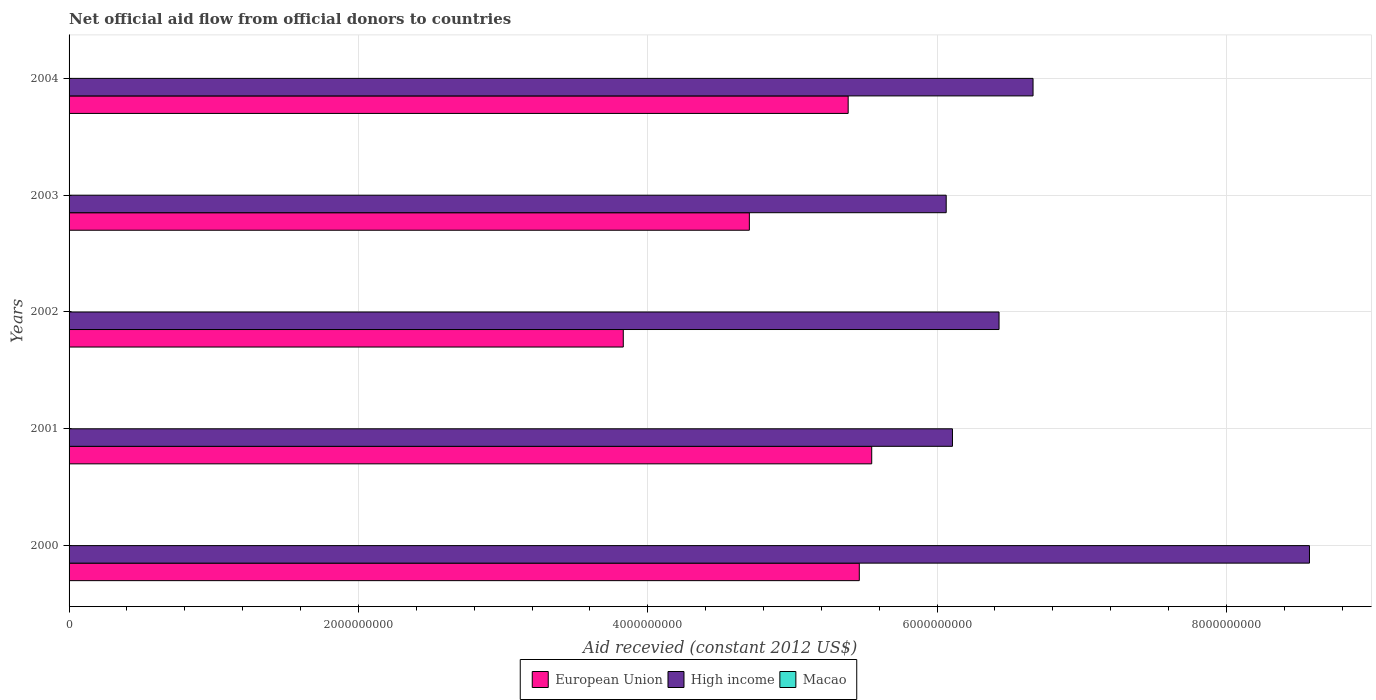How many different coloured bars are there?
Keep it short and to the point. 3. How many groups of bars are there?
Your answer should be very brief. 5. Are the number of bars per tick equal to the number of legend labels?
Offer a very short reply. Yes. How many bars are there on the 3rd tick from the bottom?
Offer a very short reply. 3. What is the label of the 3rd group of bars from the top?
Your answer should be very brief. 2002. What is the total aid received in European Union in 2003?
Offer a terse response. 4.70e+09. Across all years, what is the maximum total aid received in Macao?
Your answer should be compact. 1.58e+06. Across all years, what is the minimum total aid received in High income?
Your answer should be very brief. 6.06e+09. In which year was the total aid received in Macao maximum?
Make the answer very short. 2002. What is the total total aid received in High income in the graph?
Give a very brief answer. 3.38e+1. What is the difference between the total aid received in High income in 2000 and that in 2003?
Your answer should be compact. 2.51e+09. What is the difference between the total aid received in High income in 2000 and the total aid received in Macao in 2003?
Your response must be concise. 8.57e+09. What is the average total aid received in Macao per year?
Your response must be concise. 7.70e+05. In the year 2004, what is the difference between the total aid received in Macao and total aid received in High income?
Keep it short and to the point. -6.66e+09. What is the ratio of the total aid received in High income in 2001 to that in 2003?
Your answer should be very brief. 1.01. Is the difference between the total aid received in Macao in 2003 and 2004 greater than the difference between the total aid received in High income in 2003 and 2004?
Offer a terse response. Yes. What is the difference between the highest and the second highest total aid received in High income?
Keep it short and to the point. 1.91e+09. What is the difference between the highest and the lowest total aid received in High income?
Make the answer very short. 2.51e+09. In how many years, is the total aid received in European Union greater than the average total aid received in European Union taken over all years?
Keep it short and to the point. 3. What does the 2nd bar from the bottom in 2004 represents?
Make the answer very short. High income. How many bars are there?
Your answer should be compact. 15. Are all the bars in the graph horizontal?
Your response must be concise. Yes. How many years are there in the graph?
Give a very brief answer. 5. What is the difference between two consecutive major ticks on the X-axis?
Ensure brevity in your answer.  2.00e+09. Does the graph contain grids?
Offer a terse response. Yes. Where does the legend appear in the graph?
Offer a very short reply. Bottom center. How are the legend labels stacked?
Offer a very short reply. Horizontal. What is the title of the graph?
Keep it short and to the point. Net official aid flow from official donors to countries. What is the label or title of the X-axis?
Give a very brief answer. Aid recevied (constant 2012 US$). What is the Aid recevied (constant 2012 US$) of European Union in 2000?
Your response must be concise. 5.46e+09. What is the Aid recevied (constant 2012 US$) in High income in 2000?
Keep it short and to the point. 8.57e+09. What is the Aid recevied (constant 2012 US$) in Macao in 2000?
Your response must be concise. 1.08e+06. What is the Aid recevied (constant 2012 US$) of European Union in 2001?
Provide a succinct answer. 5.55e+09. What is the Aid recevied (constant 2012 US$) of High income in 2001?
Your answer should be very brief. 6.11e+09. What is the Aid recevied (constant 2012 US$) in Macao in 2001?
Your answer should be compact. 8.60e+05. What is the Aid recevied (constant 2012 US$) of European Union in 2002?
Provide a short and direct response. 3.83e+09. What is the Aid recevied (constant 2012 US$) in High income in 2002?
Your response must be concise. 6.43e+09. What is the Aid recevied (constant 2012 US$) of Macao in 2002?
Your response must be concise. 1.58e+06. What is the Aid recevied (constant 2012 US$) of European Union in 2003?
Your answer should be very brief. 4.70e+09. What is the Aid recevied (constant 2012 US$) of High income in 2003?
Ensure brevity in your answer.  6.06e+09. What is the Aid recevied (constant 2012 US$) of Macao in 2003?
Keep it short and to the point. 1.80e+05. What is the Aid recevied (constant 2012 US$) in European Union in 2004?
Provide a short and direct response. 5.39e+09. What is the Aid recevied (constant 2012 US$) of High income in 2004?
Make the answer very short. 6.66e+09. What is the Aid recevied (constant 2012 US$) in Macao in 2004?
Your answer should be compact. 1.50e+05. Across all years, what is the maximum Aid recevied (constant 2012 US$) of European Union?
Offer a terse response. 5.55e+09. Across all years, what is the maximum Aid recevied (constant 2012 US$) of High income?
Provide a succinct answer. 8.57e+09. Across all years, what is the maximum Aid recevied (constant 2012 US$) of Macao?
Your answer should be compact. 1.58e+06. Across all years, what is the minimum Aid recevied (constant 2012 US$) in European Union?
Provide a succinct answer. 3.83e+09. Across all years, what is the minimum Aid recevied (constant 2012 US$) in High income?
Make the answer very short. 6.06e+09. What is the total Aid recevied (constant 2012 US$) in European Union in the graph?
Provide a succinct answer. 2.49e+1. What is the total Aid recevied (constant 2012 US$) in High income in the graph?
Provide a succinct answer. 3.38e+1. What is the total Aid recevied (constant 2012 US$) in Macao in the graph?
Your answer should be very brief. 3.85e+06. What is the difference between the Aid recevied (constant 2012 US$) of European Union in 2000 and that in 2001?
Make the answer very short. -8.58e+07. What is the difference between the Aid recevied (constant 2012 US$) of High income in 2000 and that in 2001?
Your answer should be compact. 2.47e+09. What is the difference between the Aid recevied (constant 2012 US$) of Macao in 2000 and that in 2001?
Offer a terse response. 2.20e+05. What is the difference between the Aid recevied (constant 2012 US$) of European Union in 2000 and that in 2002?
Ensure brevity in your answer.  1.63e+09. What is the difference between the Aid recevied (constant 2012 US$) of High income in 2000 and that in 2002?
Provide a succinct answer. 2.15e+09. What is the difference between the Aid recevied (constant 2012 US$) in Macao in 2000 and that in 2002?
Keep it short and to the point. -5.00e+05. What is the difference between the Aid recevied (constant 2012 US$) of European Union in 2000 and that in 2003?
Ensure brevity in your answer.  7.60e+08. What is the difference between the Aid recevied (constant 2012 US$) in High income in 2000 and that in 2003?
Your answer should be compact. 2.51e+09. What is the difference between the Aid recevied (constant 2012 US$) of Macao in 2000 and that in 2003?
Ensure brevity in your answer.  9.00e+05. What is the difference between the Aid recevied (constant 2012 US$) in European Union in 2000 and that in 2004?
Give a very brief answer. 7.69e+07. What is the difference between the Aid recevied (constant 2012 US$) of High income in 2000 and that in 2004?
Your answer should be compact. 1.91e+09. What is the difference between the Aid recevied (constant 2012 US$) in Macao in 2000 and that in 2004?
Keep it short and to the point. 9.30e+05. What is the difference between the Aid recevied (constant 2012 US$) of European Union in 2001 and that in 2002?
Ensure brevity in your answer.  1.72e+09. What is the difference between the Aid recevied (constant 2012 US$) of High income in 2001 and that in 2002?
Give a very brief answer. -3.22e+08. What is the difference between the Aid recevied (constant 2012 US$) of Macao in 2001 and that in 2002?
Keep it short and to the point. -7.20e+05. What is the difference between the Aid recevied (constant 2012 US$) of European Union in 2001 and that in 2003?
Provide a short and direct response. 8.46e+08. What is the difference between the Aid recevied (constant 2012 US$) in High income in 2001 and that in 2003?
Keep it short and to the point. 4.32e+07. What is the difference between the Aid recevied (constant 2012 US$) in Macao in 2001 and that in 2003?
Offer a very short reply. 6.80e+05. What is the difference between the Aid recevied (constant 2012 US$) of European Union in 2001 and that in 2004?
Ensure brevity in your answer.  1.63e+08. What is the difference between the Aid recevied (constant 2012 US$) in High income in 2001 and that in 2004?
Make the answer very short. -5.57e+08. What is the difference between the Aid recevied (constant 2012 US$) of Macao in 2001 and that in 2004?
Your response must be concise. 7.10e+05. What is the difference between the Aid recevied (constant 2012 US$) of European Union in 2002 and that in 2003?
Provide a short and direct response. -8.71e+08. What is the difference between the Aid recevied (constant 2012 US$) in High income in 2002 and that in 2003?
Your response must be concise. 3.65e+08. What is the difference between the Aid recevied (constant 2012 US$) in Macao in 2002 and that in 2003?
Provide a succinct answer. 1.40e+06. What is the difference between the Aid recevied (constant 2012 US$) in European Union in 2002 and that in 2004?
Offer a terse response. -1.55e+09. What is the difference between the Aid recevied (constant 2012 US$) of High income in 2002 and that in 2004?
Provide a succinct answer. -2.35e+08. What is the difference between the Aid recevied (constant 2012 US$) of Macao in 2002 and that in 2004?
Your answer should be compact. 1.43e+06. What is the difference between the Aid recevied (constant 2012 US$) of European Union in 2003 and that in 2004?
Keep it short and to the point. -6.83e+08. What is the difference between the Aid recevied (constant 2012 US$) of High income in 2003 and that in 2004?
Make the answer very short. -6.00e+08. What is the difference between the Aid recevied (constant 2012 US$) of Macao in 2003 and that in 2004?
Your answer should be very brief. 3.00e+04. What is the difference between the Aid recevied (constant 2012 US$) in European Union in 2000 and the Aid recevied (constant 2012 US$) in High income in 2001?
Make the answer very short. -6.44e+08. What is the difference between the Aid recevied (constant 2012 US$) in European Union in 2000 and the Aid recevied (constant 2012 US$) in Macao in 2001?
Your answer should be compact. 5.46e+09. What is the difference between the Aid recevied (constant 2012 US$) of High income in 2000 and the Aid recevied (constant 2012 US$) of Macao in 2001?
Your answer should be very brief. 8.57e+09. What is the difference between the Aid recevied (constant 2012 US$) of European Union in 2000 and the Aid recevied (constant 2012 US$) of High income in 2002?
Your answer should be compact. -9.66e+08. What is the difference between the Aid recevied (constant 2012 US$) of European Union in 2000 and the Aid recevied (constant 2012 US$) of Macao in 2002?
Ensure brevity in your answer.  5.46e+09. What is the difference between the Aid recevied (constant 2012 US$) of High income in 2000 and the Aid recevied (constant 2012 US$) of Macao in 2002?
Your answer should be very brief. 8.57e+09. What is the difference between the Aid recevied (constant 2012 US$) of European Union in 2000 and the Aid recevied (constant 2012 US$) of High income in 2003?
Give a very brief answer. -6.01e+08. What is the difference between the Aid recevied (constant 2012 US$) in European Union in 2000 and the Aid recevied (constant 2012 US$) in Macao in 2003?
Keep it short and to the point. 5.46e+09. What is the difference between the Aid recevied (constant 2012 US$) of High income in 2000 and the Aid recevied (constant 2012 US$) of Macao in 2003?
Offer a terse response. 8.57e+09. What is the difference between the Aid recevied (constant 2012 US$) of European Union in 2000 and the Aid recevied (constant 2012 US$) of High income in 2004?
Make the answer very short. -1.20e+09. What is the difference between the Aid recevied (constant 2012 US$) in European Union in 2000 and the Aid recevied (constant 2012 US$) in Macao in 2004?
Make the answer very short. 5.46e+09. What is the difference between the Aid recevied (constant 2012 US$) in High income in 2000 and the Aid recevied (constant 2012 US$) in Macao in 2004?
Make the answer very short. 8.57e+09. What is the difference between the Aid recevied (constant 2012 US$) in European Union in 2001 and the Aid recevied (constant 2012 US$) in High income in 2002?
Give a very brief answer. -8.80e+08. What is the difference between the Aid recevied (constant 2012 US$) in European Union in 2001 and the Aid recevied (constant 2012 US$) in Macao in 2002?
Your response must be concise. 5.55e+09. What is the difference between the Aid recevied (constant 2012 US$) of High income in 2001 and the Aid recevied (constant 2012 US$) of Macao in 2002?
Make the answer very short. 6.10e+09. What is the difference between the Aid recevied (constant 2012 US$) of European Union in 2001 and the Aid recevied (constant 2012 US$) of High income in 2003?
Offer a terse response. -5.15e+08. What is the difference between the Aid recevied (constant 2012 US$) of European Union in 2001 and the Aid recevied (constant 2012 US$) of Macao in 2003?
Make the answer very short. 5.55e+09. What is the difference between the Aid recevied (constant 2012 US$) in High income in 2001 and the Aid recevied (constant 2012 US$) in Macao in 2003?
Make the answer very short. 6.11e+09. What is the difference between the Aid recevied (constant 2012 US$) in European Union in 2001 and the Aid recevied (constant 2012 US$) in High income in 2004?
Offer a very short reply. -1.12e+09. What is the difference between the Aid recevied (constant 2012 US$) of European Union in 2001 and the Aid recevied (constant 2012 US$) of Macao in 2004?
Offer a terse response. 5.55e+09. What is the difference between the Aid recevied (constant 2012 US$) of High income in 2001 and the Aid recevied (constant 2012 US$) of Macao in 2004?
Your answer should be very brief. 6.11e+09. What is the difference between the Aid recevied (constant 2012 US$) in European Union in 2002 and the Aid recevied (constant 2012 US$) in High income in 2003?
Your answer should be compact. -2.23e+09. What is the difference between the Aid recevied (constant 2012 US$) in European Union in 2002 and the Aid recevied (constant 2012 US$) in Macao in 2003?
Ensure brevity in your answer.  3.83e+09. What is the difference between the Aid recevied (constant 2012 US$) of High income in 2002 and the Aid recevied (constant 2012 US$) of Macao in 2003?
Provide a short and direct response. 6.43e+09. What is the difference between the Aid recevied (constant 2012 US$) in European Union in 2002 and the Aid recevied (constant 2012 US$) in High income in 2004?
Keep it short and to the point. -2.83e+09. What is the difference between the Aid recevied (constant 2012 US$) in European Union in 2002 and the Aid recevied (constant 2012 US$) in Macao in 2004?
Give a very brief answer. 3.83e+09. What is the difference between the Aid recevied (constant 2012 US$) of High income in 2002 and the Aid recevied (constant 2012 US$) of Macao in 2004?
Provide a short and direct response. 6.43e+09. What is the difference between the Aid recevied (constant 2012 US$) of European Union in 2003 and the Aid recevied (constant 2012 US$) of High income in 2004?
Your answer should be compact. -1.96e+09. What is the difference between the Aid recevied (constant 2012 US$) in European Union in 2003 and the Aid recevied (constant 2012 US$) in Macao in 2004?
Provide a succinct answer. 4.70e+09. What is the difference between the Aid recevied (constant 2012 US$) in High income in 2003 and the Aid recevied (constant 2012 US$) in Macao in 2004?
Keep it short and to the point. 6.06e+09. What is the average Aid recevied (constant 2012 US$) in European Union per year?
Provide a short and direct response. 4.99e+09. What is the average Aid recevied (constant 2012 US$) in High income per year?
Your response must be concise. 6.77e+09. What is the average Aid recevied (constant 2012 US$) of Macao per year?
Provide a succinct answer. 7.70e+05. In the year 2000, what is the difference between the Aid recevied (constant 2012 US$) of European Union and Aid recevied (constant 2012 US$) of High income?
Offer a terse response. -3.11e+09. In the year 2000, what is the difference between the Aid recevied (constant 2012 US$) of European Union and Aid recevied (constant 2012 US$) of Macao?
Ensure brevity in your answer.  5.46e+09. In the year 2000, what is the difference between the Aid recevied (constant 2012 US$) in High income and Aid recevied (constant 2012 US$) in Macao?
Offer a terse response. 8.57e+09. In the year 2001, what is the difference between the Aid recevied (constant 2012 US$) of European Union and Aid recevied (constant 2012 US$) of High income?
Provide a short and direct response. -5.58e+08. In the year 2001, what is the difference between the Aid recevied (constant 2012 US$) of European Union and Aid recevied (constant 2012 US$) of Macao?
Offer a very short reply. 5.55e+09. In the year 2001, what is the difference between the Aid recevied (constant 2012 US$) in High income and Aid recevied (constant 2012 US$) in Macao?
Keep it short and to the point. 6.11e+09. In the year 2002, what is the difference between the Aid recevied (constant 2012 US$) in European Union and Aid recevied (constant 2012 US$) in High income?
Give a very brief answer. -2.60e+09. In the year 2002, what is the difference between the Aid recevied (constant 2012 US$) in European Union and Aid recevied (constant 2012 US$) in Macao?
Offer a terse response. 3.83e+09. In the year 2002, what is the difference between the Aid recevied (constant 2012 US$) in High income and Aid recevied (constant 2012 US$) in Macao?
Offer a very short reply. 6.43e+09. In the year 2003, what is the difference between the Aid recevied (constant 2012 US$) in European Union and Aid recevied (constant 2012 US$) in High income?
Offer a very short reply. -1.36e+09. In the year 2003, what is the difference between the Aid recevied (constant 2012 US$) in European Union and Aid recevied (constant 2012 US$) in Macao?
Your answer should be very brief. 4.70e+09. In the year 2003, what is the difference between the Aid recevied (constant 2012 US$) of High income and Aid recevied (constant 2012 US$) of Macao?
Provide a succinct answer. 6.06e+09. In the year 2004, what is the difference between the Aid recevied (constant 2012 US$) of European Union and Aid recevied (constant 2012 US$) of High income?
Give a very brief answer. -1.28e+09. In the year 2004, what is the difference between the Aid recevied (constant 2012 US$) of European Union and Aid recevied (constant 2012 US$) of Macao?
Offer a very short reply. 5.39e+09. In the year 2004, what is the difference between the Aid recevied (constant 2012 US$) in High income and Aid recevied (constant 2012 US$) in Macao?
Offer a very short reply. 6.66e+09. What is the ratio of the Aid recevied (constant 2012 US$) of European Union in 2000 to that in 2001?
Give a very brief answer. 0.98. What is the ratio of the Aid recevied (constant 2012 US$) of High income in 2000 to that in 2001?
Your response must be concise. 1.4. What is the ratio of the Aid recevied (constant 2012 US$) of Macao in 2000 to that in 2001?
Make the answer very short. 1.26. What is the ratio of the Aid recevied (constant 2012 US$) of European Union in 2000 to that in 2002?
Keep it short and to the point. 1.43. What is the ratio of the Aid recevied (constant 2012 US$) of High income in 2000 to that in 2002?
Your answer should be very brief. 1.33. What is the ratio of the Aid recevied (constant 2012 US$) in Macao in 2000 to that in 2002?
Make the answer very short. 0.68. What is the ratio of the Aid recevied (constant 2012 US$) of European Union in 2000 to that in 2003?
Offer a very short reply. 1.16. What is the ratio of the Aid recevied (constant 2012 US$) in High income in 2000 to that in 2003?
Your answer should be very brief. 1.41. What is the ratio of the Aid recevied (constant 2012 US$) of European Union in 2000 to that in 2004?
Ensure brevity in your answer.  1.01. What is the ratio of the Aid recevied (constant 2012 US$) of High income in 2000 to that in 2004?
Your answer should be compact. 1.29. What is the ratio of the Aid recevied (constant 2012 US$) in Macao in 2000 to that in 2004?
Ensure brevity in your answer.  7.2. What is the ratio of the Aid recevied (constant 2012 US$) in European Union in 2001 to that in 2002?
Your answer should be compact. 1.45. What is the ratio of the Aid recevied (constant 2012 US$) of High income in 2001 to that in 2002?
Your answer should be very brief. 0.95. What is the ratio of the Aid recevied (constant 2012 US$) of Macao in 2001 to that in 2002?
Provide a short and direct response. 0.54. What is the ratio of the Aid recevied (constant 2012 US$) in European Union in 2001 to that in 2003?
Your answer should be very brief. 1.18. What is the ratio of the Aid recevied (constant 2012 US$) of High income in 2001 to that in 2003?
Give a very brief answer. 1.01. What is the ratio of the Aid recevied (constant 2012 US$) in Macao in 2001 to that in 2003?
Offer a terse response. 4.78. What is the ratio of the Aid recevied (constant 2012 US$) of European Union in 2001 to that in 2004?
Keep it short and to the point. 1.03. What is the ratio of the Aid recevied (constant 2012 US$) in High income in 2001 to that in 2004?
Give a very brief answer. 0.92. What is the ratio of the Aid recevied (constant 2012 US$) in Macao in 2001 to that in 2004?
Ensure brevity in your answer.  5.73. What is the ratio of the Aid recevied (constant 2012 US$) in European Union in 2002 to that in 2003?
Your answer should be compact. 0.81. What is the ratio of the Aid recevied (constant 2012 US$) of High income in 2002 to that in 2003?
Offer a very short reply. 1.06. What is the ratio of the Aid recevied (constant 2012 US$) in Macao in 2002 to that in 2003?
Keep it short and to the point. 8.78. What is the ratio of the Aid recevied (constant 2012 US$) of European Union in 2002 to that in 2004?
Give a very brief answer. 0.71. What is the ratio of the Aid recevied (constant 2012 US$) of High income in 2002 to that in 2004?
Your answer should be very brief. 0.96. What is the ratio of the Aid recevied (constant 2012 US$) in Macao in 2002 to that in 2004?
Offer a very short reply. 10.53. What is the ratio of the Aid recevied (constant 2012 US$) in European Union in 2003 to that in 2004?
Offer a terse response. 0.87. What is the ratio of the Aid recevied (constant 2012 US$) in High income in 2003 to that in 2004?
Provide a succinct answer. 0.91. What is the ratio of the Aid recevied (constant 2012 US$) in Macao in 2003 to that in 2004?
Provide a succinct answer. 1.2. What is the difference between the highest and the second highest Aid recevied (constant 2012 US$) of European Union?
Provide a succinct answer. 8.58e+07. What is the difference between the highest and the second highest Aid recevied (constant 2012 US$) of High income?
Ensure brevity in your answer.  1.91e+09. What is the difference between the highest and the second highest Aid recevied (constant 2012 US$) in Macao?
Offer a very short reply. 5.00e+05. What is the difference between the highest and the lowest Aid recevied (constant 2012 US$) of European Union?
Give a very brief answer. 1.72e+09. What is the difference between the highest and the lowest Aid recevied (constant 2012 US$) in High income?
Provide a succinct answer. 2.51e+09. What is the difference between the highest and the lowest Aid recevied (constant 2012 US$) in Macao?
Provide a short and direct response. 1.43e+06. 